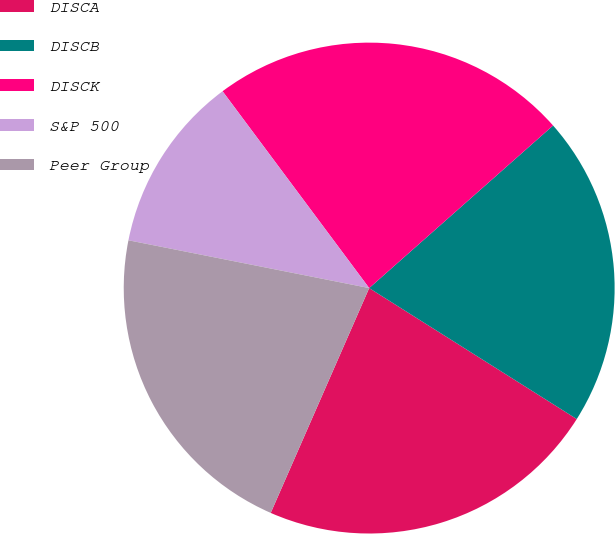<chart> <loc_0><loc_0><loc_500><loc_500><pie_chart><fcel>DISCA<fcel>DISCB<fcel>DISCK<fcel>S&P 500<fcel>Peer Group<nl><fcel>22.61%<fcel>20.48%<fcel>23.67%<fcel>11.69%<fcel>21.55%<nl></chart> 